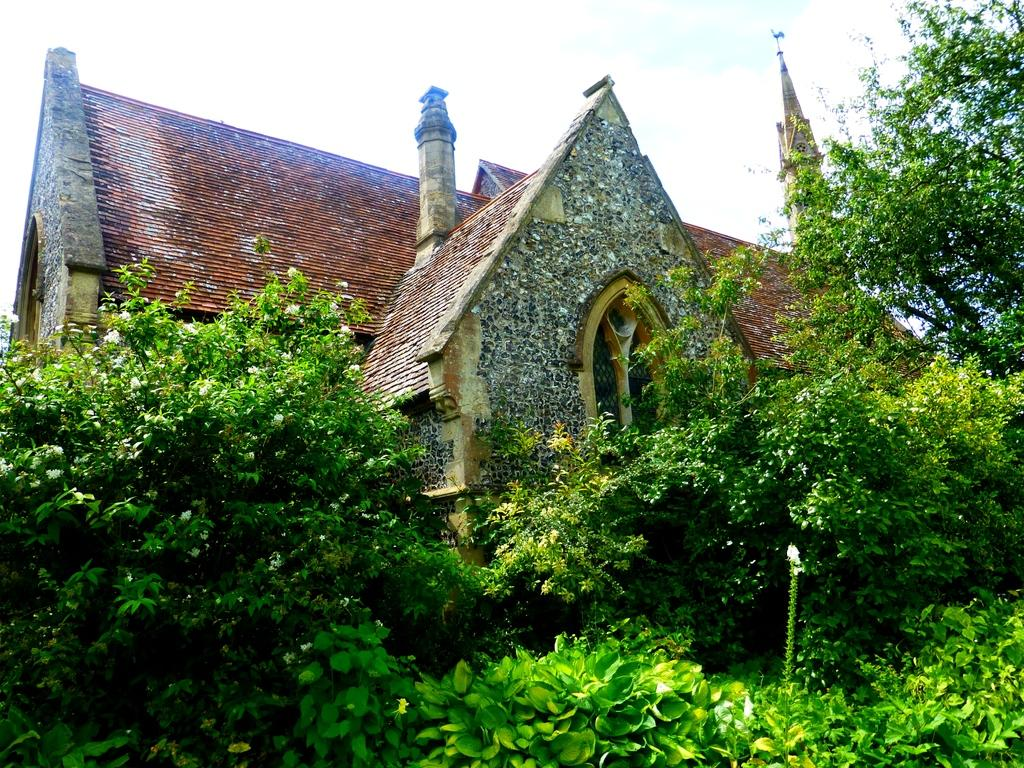What type of vegetation can be seen in the image? There are plants and trees in the image. What type of structure is present in the image? There is a stone house in the image. What can be seen in the background of the image? The sky is visible in the background of the image. Where is the drawer located in the image? There is no drawer present in the image. What color is the silver in the image? There is no silver present in the image. 